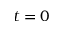Convert formula to latex. <formula><loc_0><loc_0><loc_500><loc_500>t = 0</formula> 